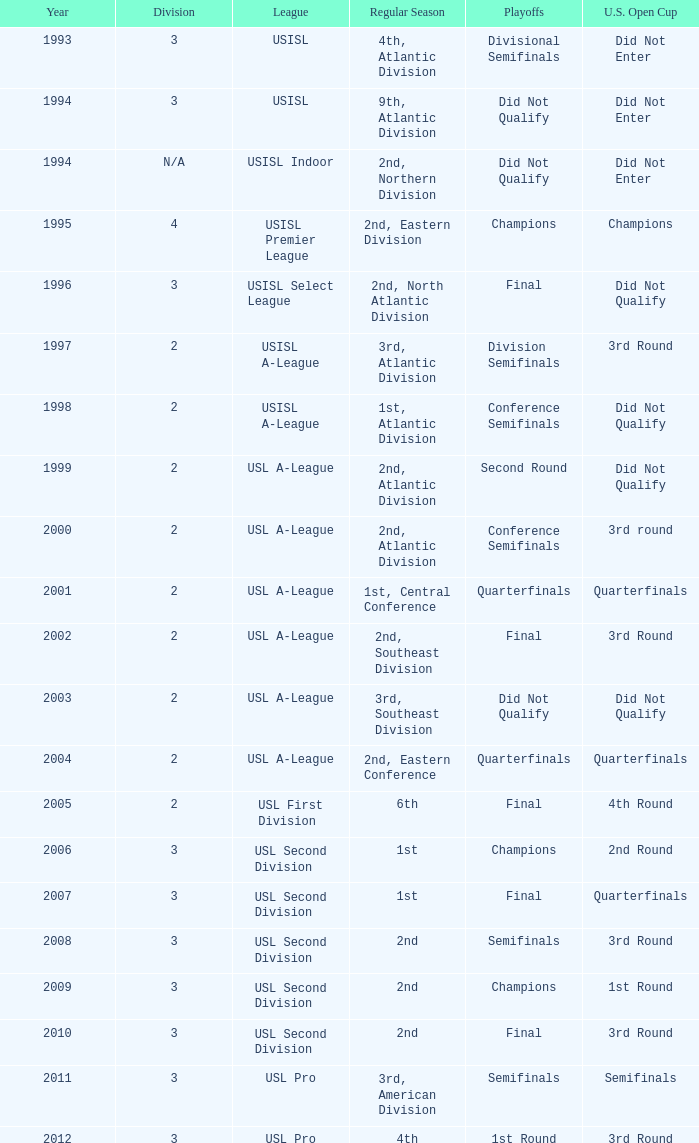What are all the playoffs for u.s. open cup in 1st round Champions. 